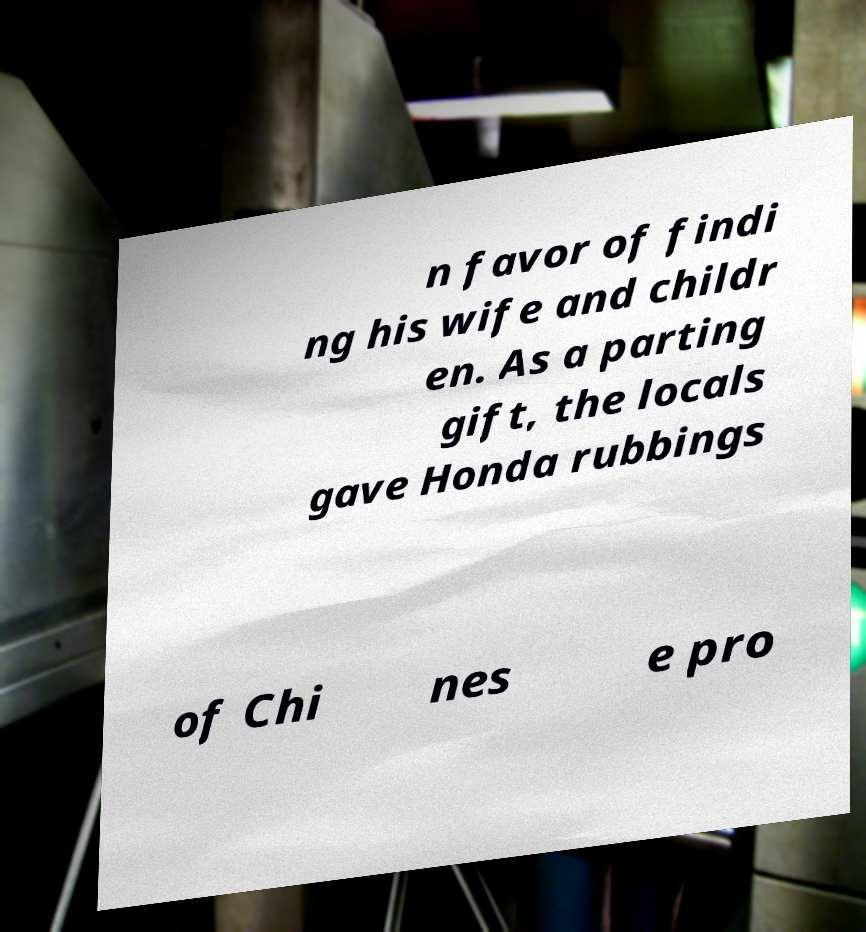Could you assist in decoding the text presented in this image and type it out clearly? n favor of findi ng his wife and childr en. As a parting gift, the locals gave Honda rubbings of Chi nes e pro 